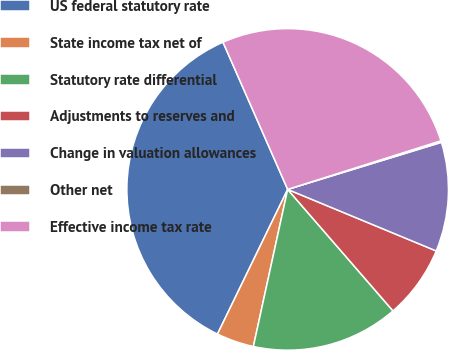Convert chart. <chart><loc_0><loc_0><loc_500><loc_500><pie_chart><fcel>US federal statutory rate<fcel>State income tax net of<fcel>Statutory rate differential<fcel>Adjustments to reserves and<fcel>Change in valuation allowances<fcel>Other net<fcel>Effective income tax rate<nl><fcel>36.22%<fcel>3.77%<fcel>14.79%<fcel>7.38%<fcel>10.98%<fcel>0.16%<fcel>26.7%<nl></chart> 